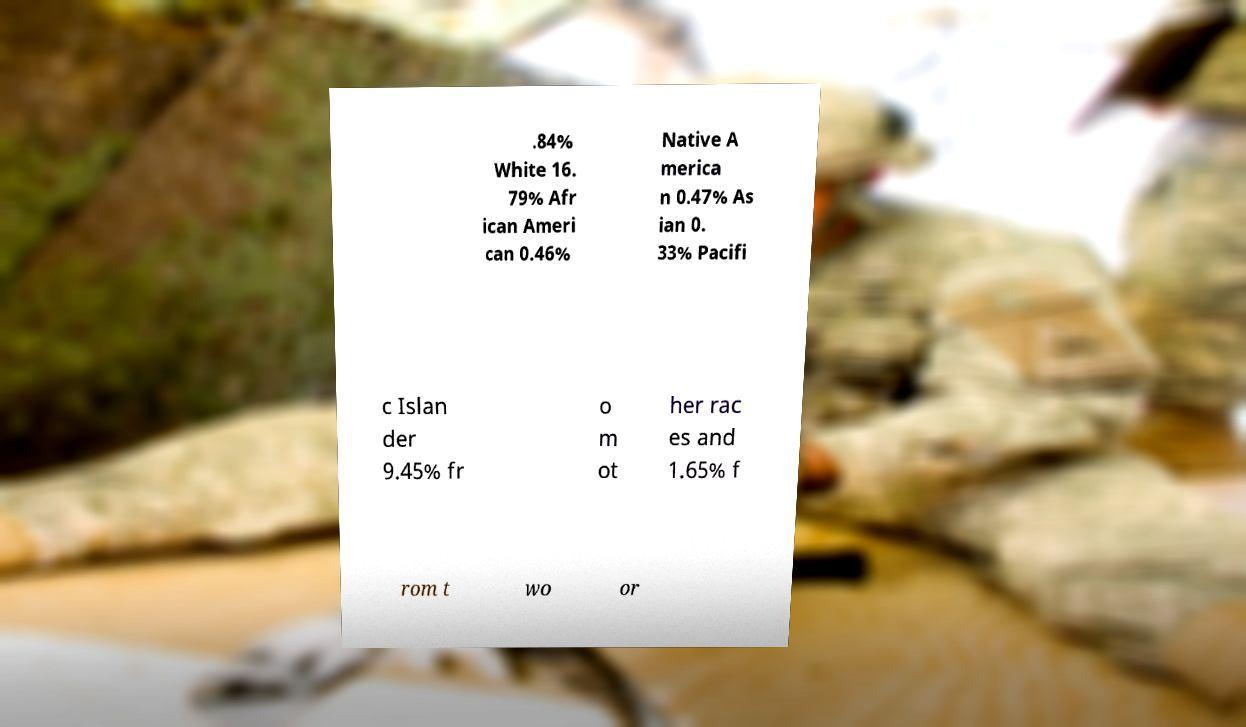What messages or text are displayed in this image? I need them in a readable, typed format. .84% White 16. 79% Afr ican Ameri can 0.46% Native A merica n 0.47% As ian 0. 33% Pacifi c Islan der 9.45% fr o m ot her rac es and 1.65% f rom t wo or 